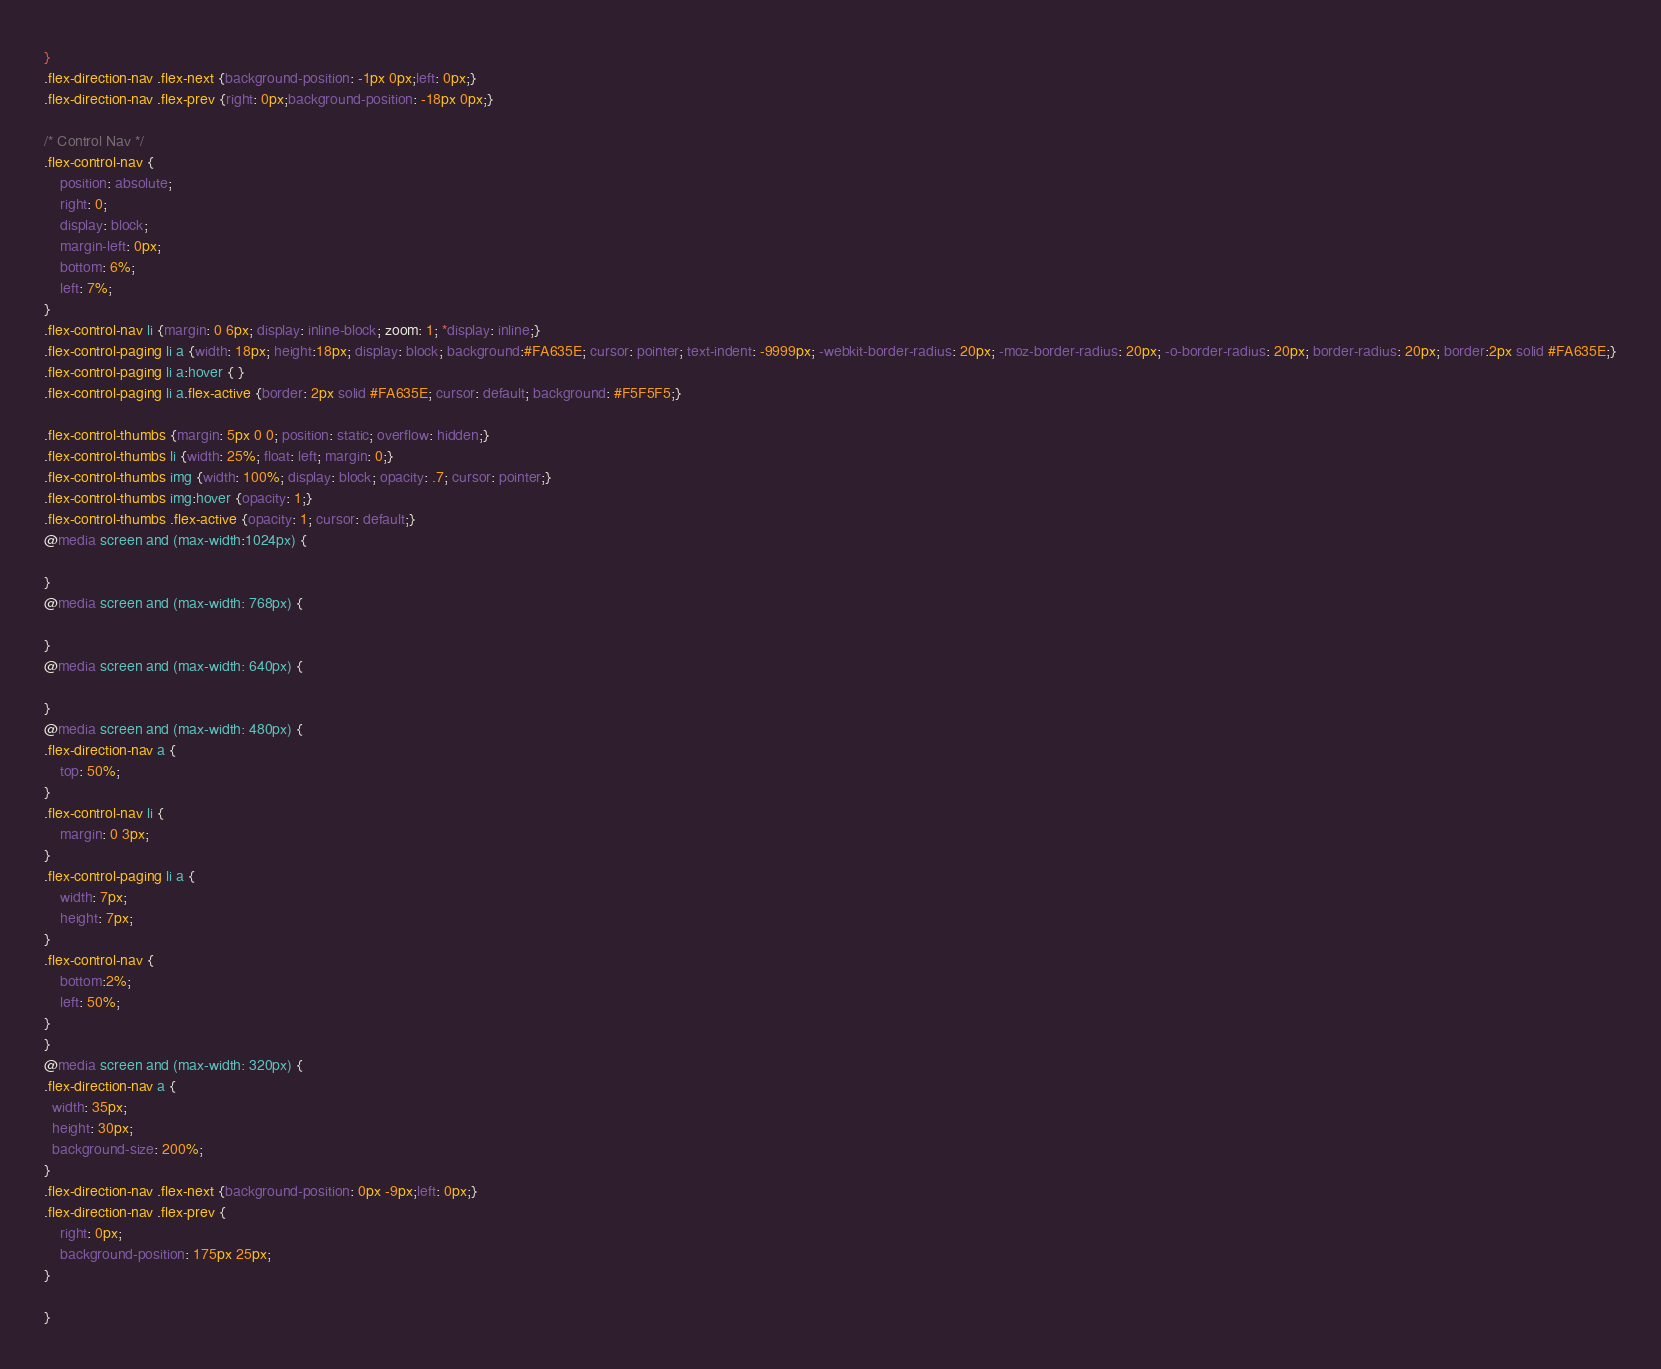<code> <loc_0><loc_0><loc_500><loc_500><_CSS_>}
.flex-direction-nav .flex-next {background-position: -1px 0px;left: 0px;}
.flex-direction-nav .flex-prev {right: 0px;background-position: -18px 0px;}

/* Control Nav */
.flex-control-nav {
    position: absolute;
    right: 0;
    display: block;
    margin-left: 0px;
    bottom: 6%;
    left: 7%;
}
.flex-control-nav li {margin: 0 6px; display: inline-block; zoom: 1; *display: inline;}
.flex-control-paging li a {width: 18px; height:18px; display: block; background:#FA635E; cursor: pointer; text-indent: -9999px; -webkit-border-radius: 20px; -moz-border-radius: 20px; -o-border-radius: 20px; border-radius: 20px; border:2px solid #FA635E;}
.flex-control-paging li a:hover { }
.flex-control-paging li a.flex-active {border: 2px solid #FA635E; cursor: default; background: #F5F5F5;}

.flex-control-thumbs {margin: 5px 0 0; position: static; overflow: hidden;}
.flex-control-thumbs li {width: 25%; float: left; margin: 0;}
.flex-control-thumbs img {width: 100%; display: block; opacity: .7; cursor: pointer;}
.flex-control-thumbs img:hover {opacity: 1;}
.flex-control-thumbs .flex-active {opacity: 1; cursor: default;}
@media screen and (max-width:1024px) {

}
@media screen and (max-width: 768px) {
 
}
@media screen and (max-width: 640px) {

}
@media screen and (max-width: 480px) {
.flex-direction-nav a {
    top: 50%;
}
.flex-control-nav li {
    margin: 0 3px;
}
.flex-control-paging li a {
    width: 7px;
    height: 7px;
}
.flex-control-nav {
    bottom:2%;
    left: 50%;
}
}
@media screen and (max-width: 320px) {
.flex-direction-nav a {
  width: 35px;
  height: 30px;
  background-size: 200%;
}
.flex-direction-nav .flex-next {background-position: 0px -9px;left: 0px;}
.flex-direction-nav .flex-prev {
    right: 0px;
    background-position: 175px 25px;
}

}</code> 